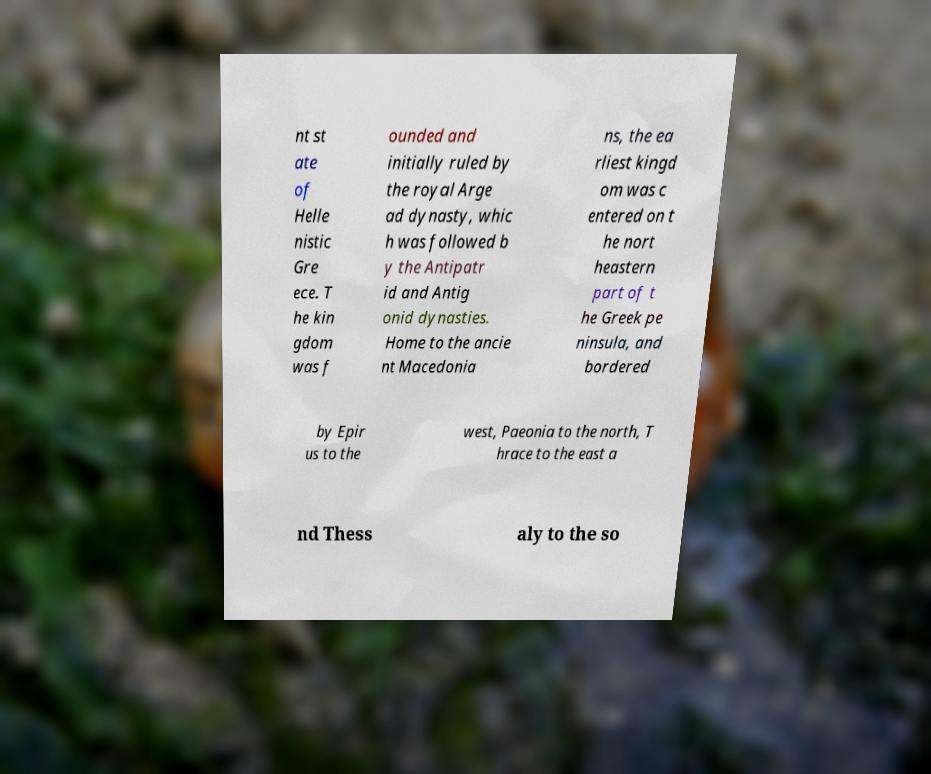I need the written content from this picture converted into text. Can you do that? nt st ate of Helle nistic Gre ece. T he kin gdom was f ounded and initially ruled by the royal Arge ad dynasty, whic h was followed b y the Antipatr id and Antig onid dynasties. Home to the ancie nt Macedonia ns, the ea rliest kingd om was c entered on t he nort heastern part of t he Greek pe ninsula, and bordered by Epir us to the west, Paeonia to the north, T hrace to the east a nd Thess aly to the so 